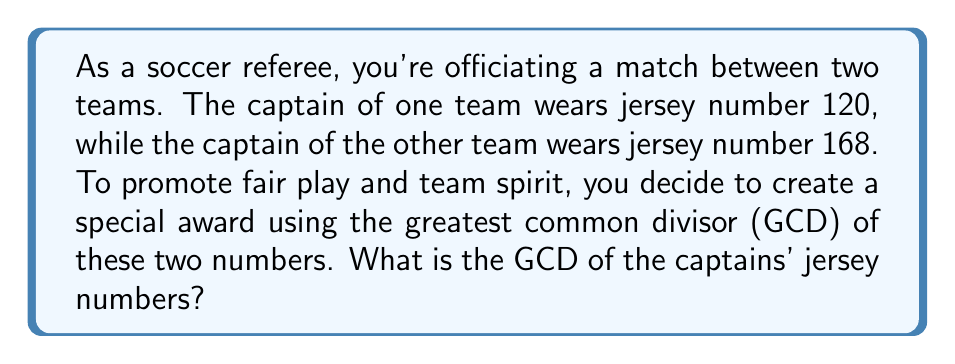Give your solution to this math problem. To find the greatest common divisor (GCD) of 120 and 168, we can use the Euclidean algorithm:

1) First, divide 168 by 120:
   $168 = 1 \times 120 + 48$

2) Now, divide 120 by 48:
   $120 = 2 \times 48 + 24$

3) Continue dividing:
   $48 = 2 \times 24 + 0$

4) The process stops when we get a remainder of 0. The last non-zero remainder is the GCD.

Therefore, the GCD of 120 and 168 is 24.

We can verify this result:
$120 = 2^3 \times 3 \times 5$
$168 = 2^3 \times 3 \times 7$

The common factors are $2^3 \times 3 = 24$

This method is particularly useful for a referee, as it can be done quickly without a calculator, using just simple division.
Answer: The greatest common divisor of 120 and 168 is 24. 